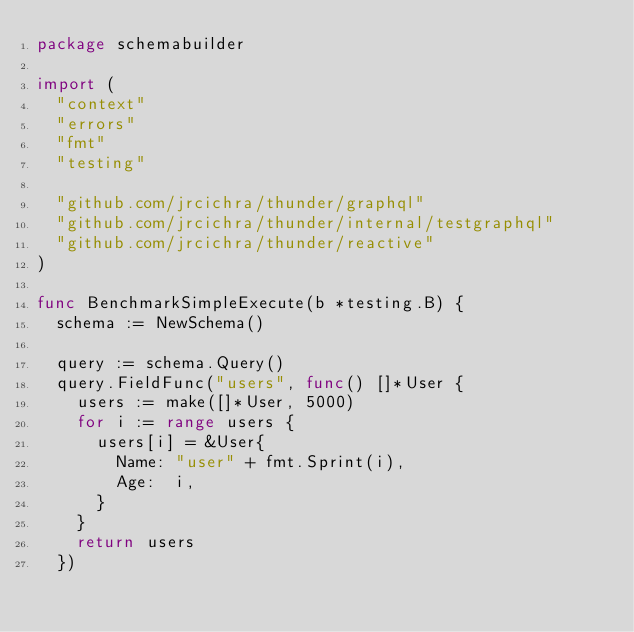<code> <loc_0><loc_0><loc_500><loc_500><_Go_>package schemabuilder

import (
	"context"
	"errors"
	"fmt"
	"testing"

	"github.com/jrcichra/thunder/graphql"
	"github.com/jrcichra/thunder/internal/testgraphql"
	"github.com/jrcichra/thunder/reactive"
)

func BenchmarkSimpleExecute(b *testing.B) {
	schema := NewSchema()

	query := schema.Query()
	query.FieldFunc("users", func() []*User {
		users := make([]*User, 5000)
		for i := range users {
			users[i] = &User{
				Name: "user" + fmt.Sprint(i),
				Age:  i,
			}
		}
		return users
	})
</code> 